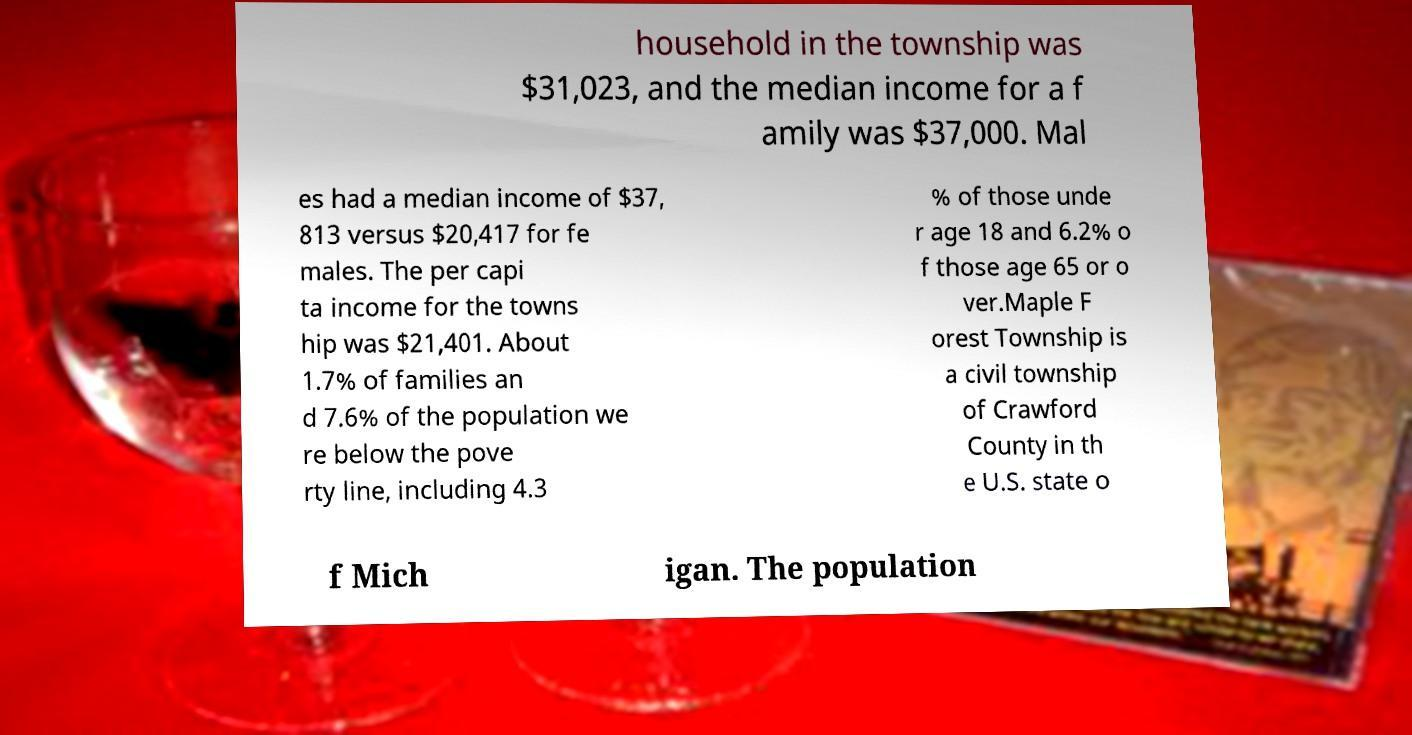Could you assist in decoding the text presented in this image and type it out clearly? household in the township was $31,023, and the median income for a f amily was $37,000. Mal es had a median income of $37, 813 versus $20,417 for fe males. The per capi ta income for the towns hip was $21,401. About 1.7% of families an d 7.6% of the population we re below the pove rty line, including 4.3 % of those unde r age 18 and 6.2% o f those age 65 or o ver.Maple F orest Township is a civil township of Crawford County in th e U.S. state o f Mich igan. The population 